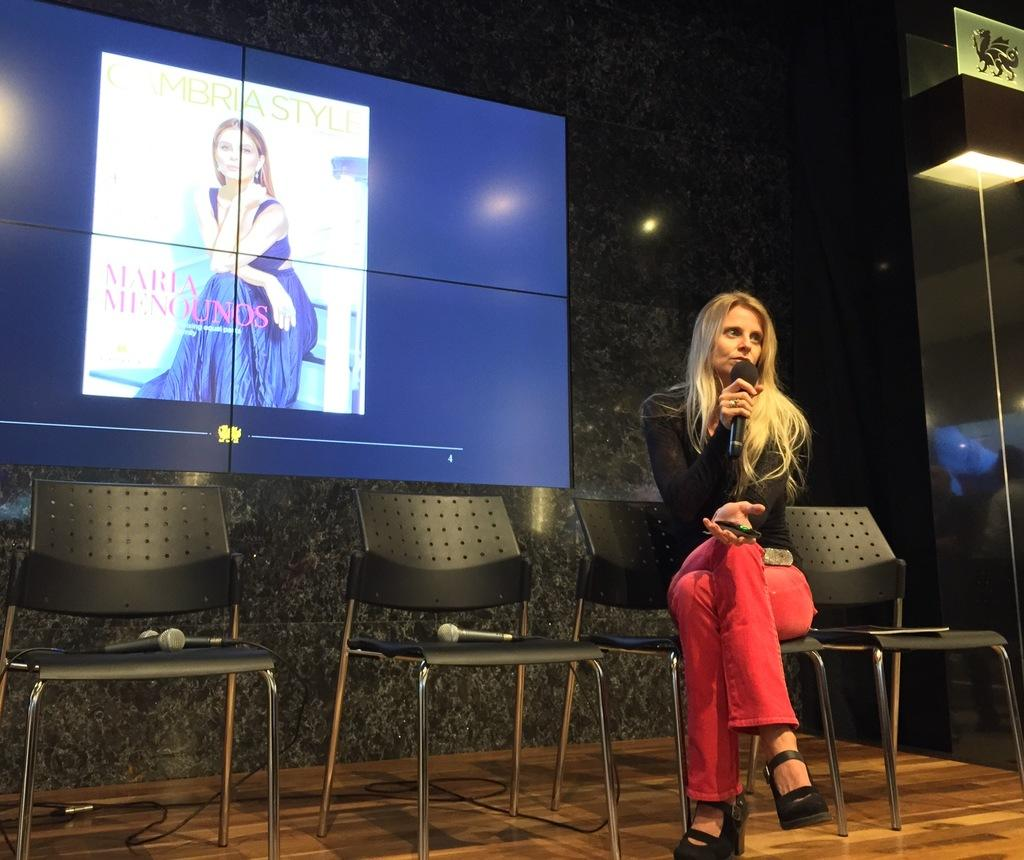Who is the main subject in the image? There is a woman in the image. What is the woman doing in the image? The woman is seated on a chair and speaking using a microphone. What can be seen behind the woman in the image? There is a screen visible behind the woman. What is the chance of the woman falling into quicksand in the image? There is no quicksand present in the image, so it is not possible to determine the chance of the woman falling into it. 